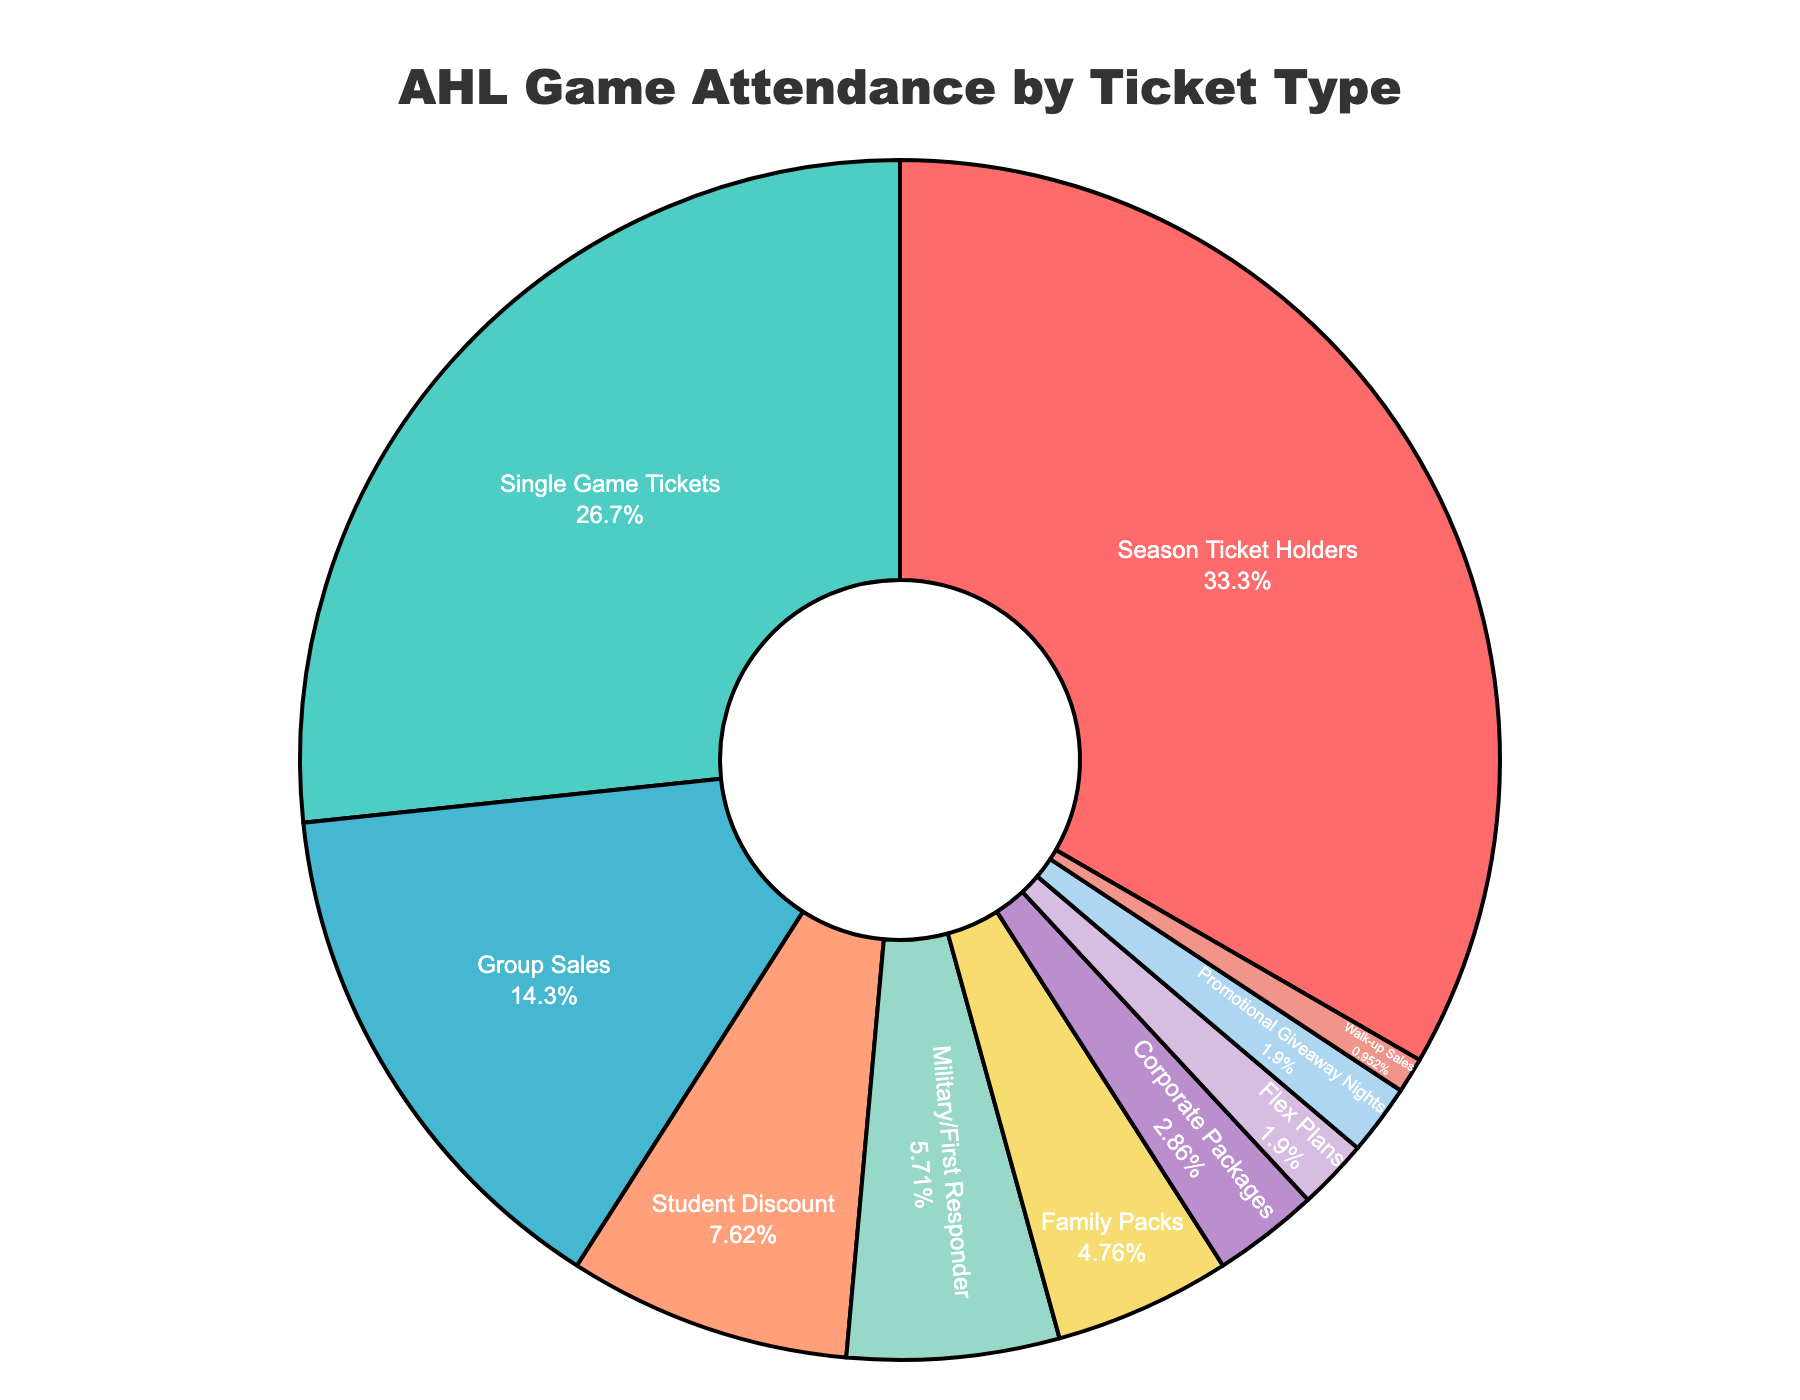What's the percentage of game attendees from Single Game Tickets and Group Sales combined? To find the combined percentage of Single Game Tickets and Group Sales, add their respective percentages: 28% + 15% = 43%
Answer: 43 Which ticket type accounts for the largest portion of game attendance? By visually identifying the largest slice in the pie chart, Season Ticket Holders have the highest percentage at 35%.
Answer: Season Ticket Holders What is the difference in percentage between Season Ticket Holders and Single Game Tickets? Subtract the percentage of Single Game Tickets from the percentage of Season Ticket Holders: 35% - 28% = 7%
Answer: 7 How many ticket types compose less than 5% of game attendance each? Visually identify and count all ticket types with slices that represent less than 5%: Corporate Packages, Flex Plans, Promotional Giveaway Nights, and Walk-up Sales. There are 4 ticket types.
Answer: 4 What is the combined percentage of game attendees from Military/First Responder and Family Packs? Add the percentages of Military/First Responder and Family Packs: 6% + 5% = 11%
Answer: 11 